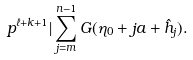<formula> <loc_0><loc_0><loc_500><loc_500>p ^ { \ell + k + 1 } | \sum _ { j = m } ^ { n - 1 } G ( \eta _ { 0 } + j a + \hat { h } _ { j } ) .</formula> 